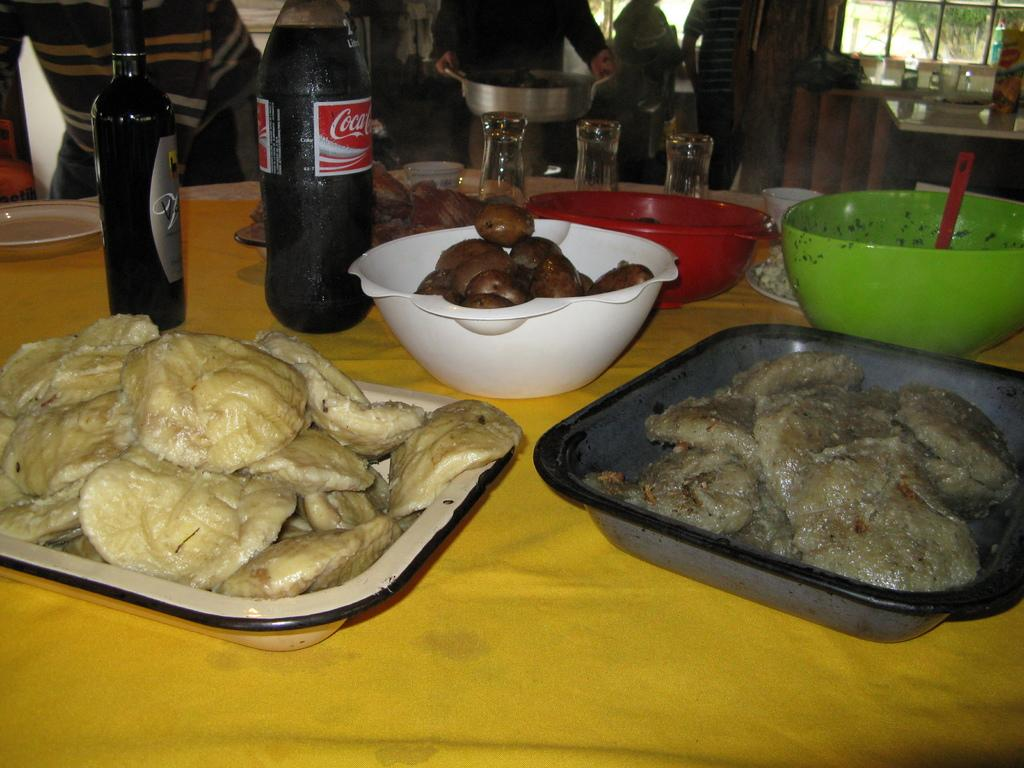What type of items can be seen on the table in the image? There is food, trays, bottles, bowls, and glasses on the table in the image. How are the food items presented in the image? The food items are on trays in the image. What type of containers are used for the liquids in the image? Bottles and glasses are used for the liquids in the image. What type of dishware is present in the image? Bowls are present in the image. What type of credit can be seen on the trays in the image? There is no credit present on the trays in the image. Who is the achiever being celebrated in the image? There is no indication of a celebration or an achiever in the image. 